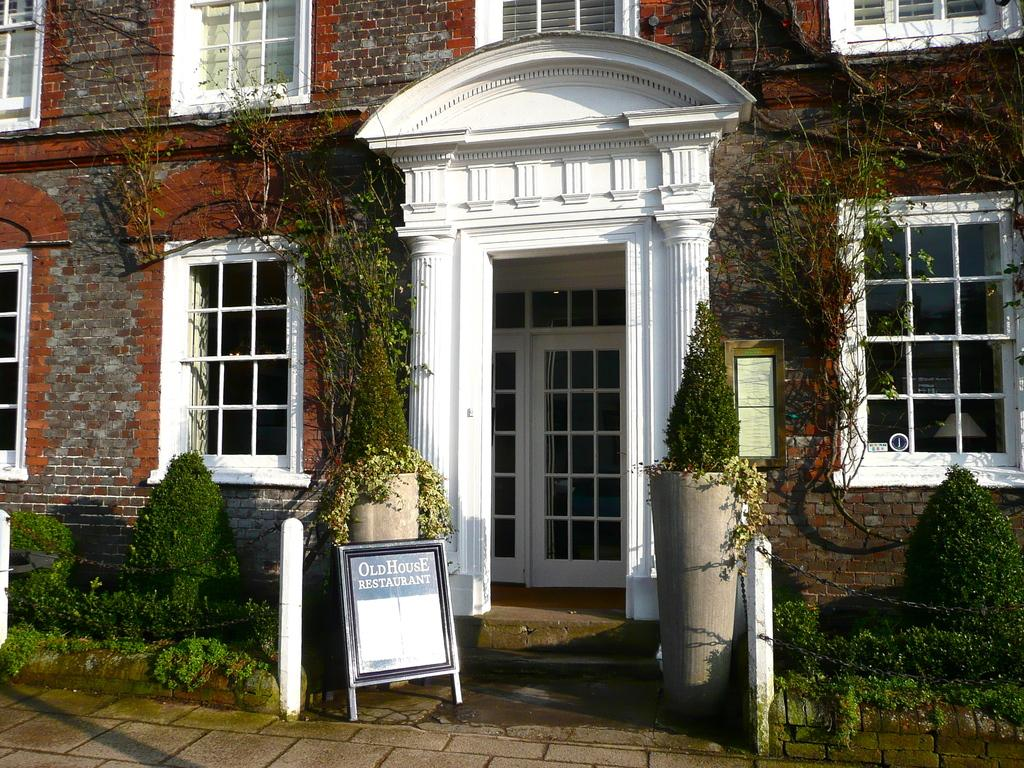What type of structure is in the picture? There is a building in the picture. What features can be seen on the building? The building has windows and doors. What is written or displayed on a board in the picture? There is a board with writing in the picture. What type of vegetation is present in the picture? There are plants and grass in the picture. What other objects are on the ground in the picture? There are other objects on the ground in the picture. What color is the shirt worn by the mailbox in the picture? There is no mailbox or shirt present in the picture. What act is the building performing in the picture? Buildings do not perform acts; they are inanimate structures. 